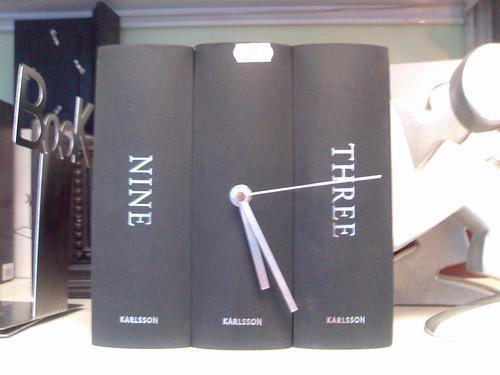How many clocks are there?
Give a very brief answer. 1. How many silver inlaid names of karlsson?
Give a very brief answer. 3. How many "e's" are there in the words "three" and "nine"?
Give a very brief answer. 3. 